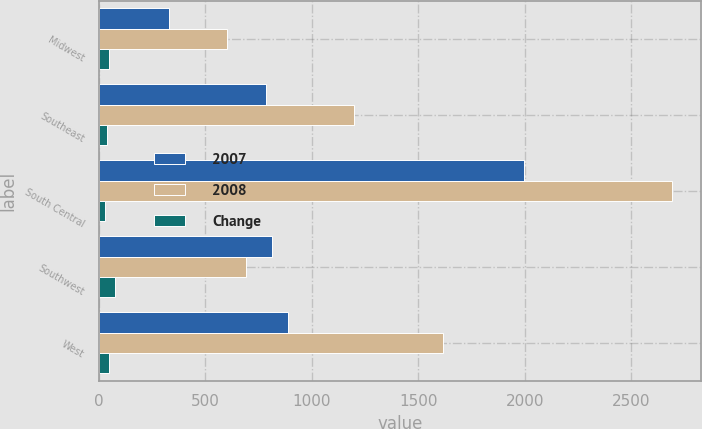Convert chart. <chart><loc_0><loc_0><loc_500><loc_500><stacked_bar_chart><ecel><fcel>Midwest<fcel>Southeast<fcel>South Central<fcel>Southwest<fcel>West<nl><fcel>2007<fcel>328<fcel>783<fcel>1999<fcel>812<fcel>888<nl><fcel>2008<fcel>600<fcel>1198<fcel>2693<fcel>691.5<fcel>1618<nl><fcel>Change<fcel>45<fcel>35<fcel>26<fcel>74<fcel>45<nl></chart> 